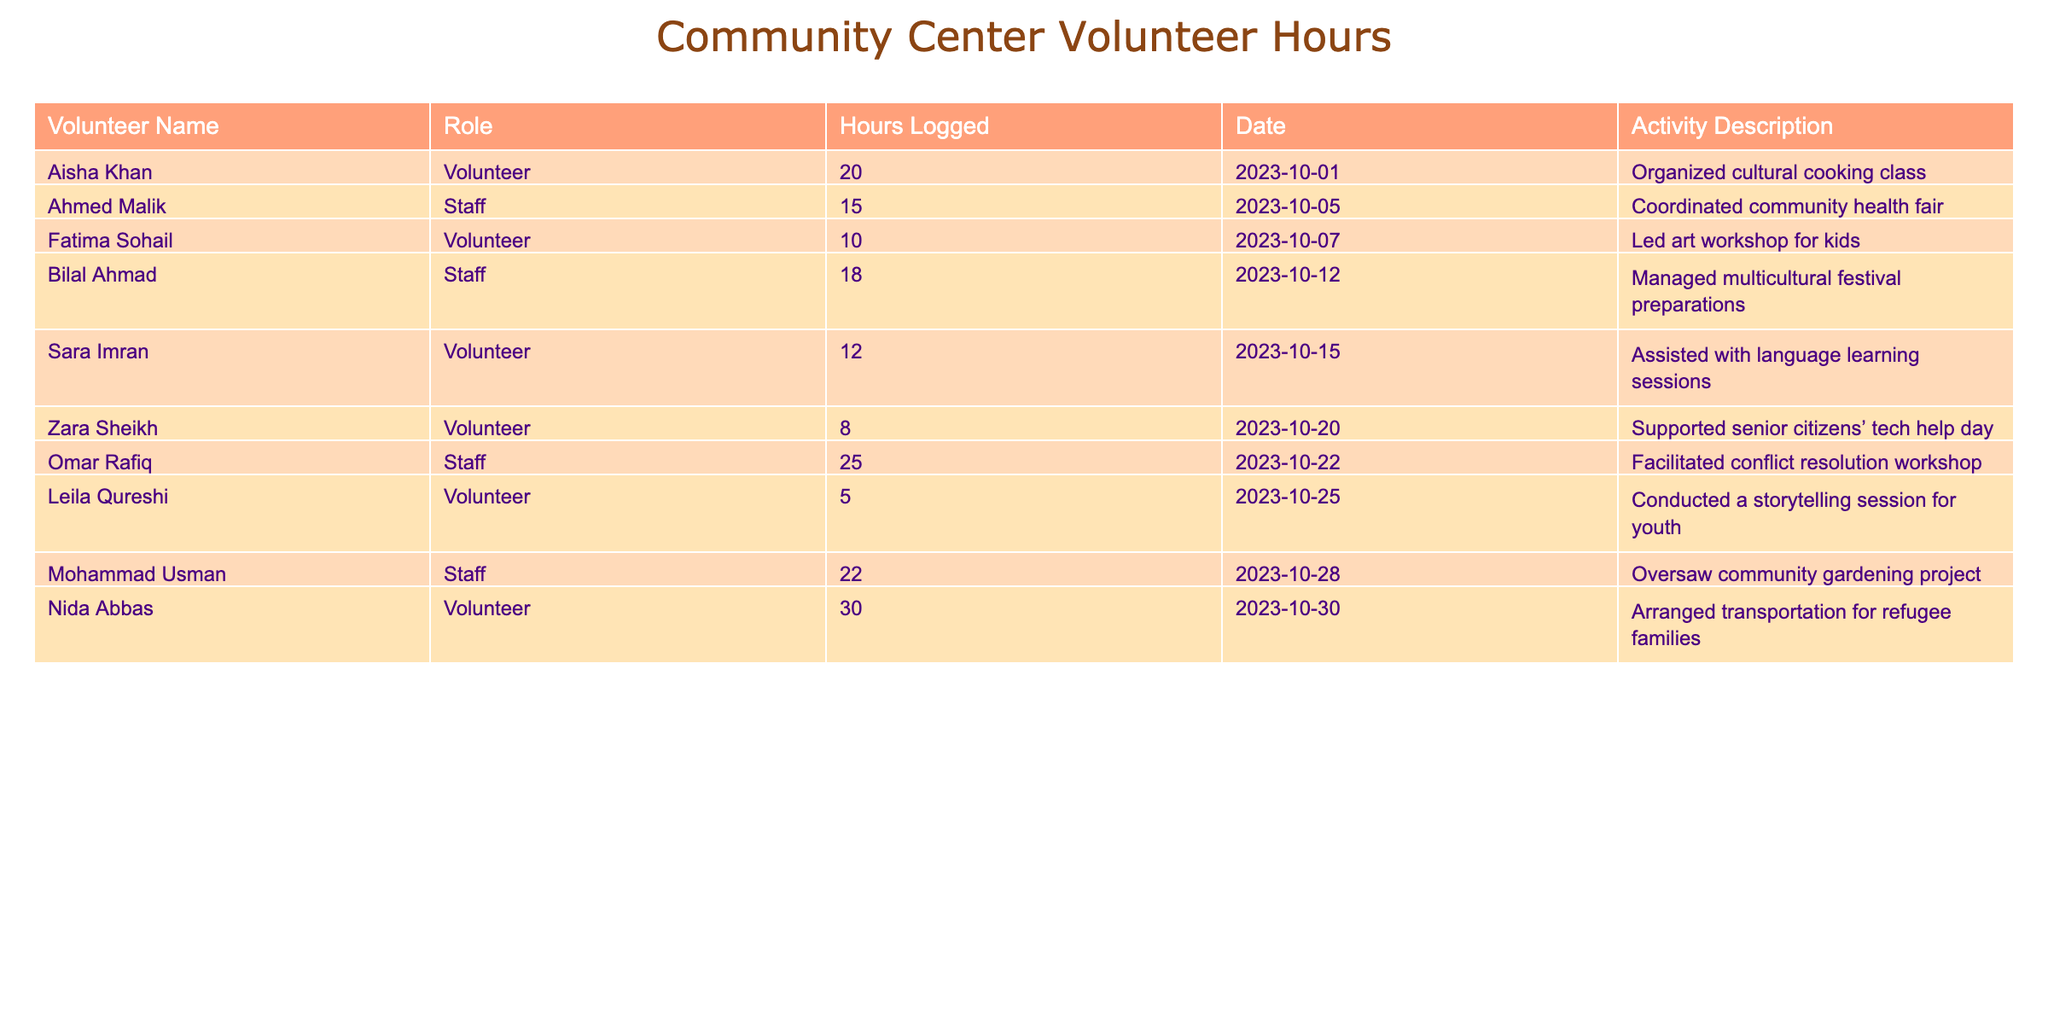What is the total number of volunteer hours logged by all participants? To find the total hours, sum hours for all entries: 20 + 15 + 10 + 18 + 12 + 8 + 25 + 5 + 22 + 30 =  165 hours.
Answer: 165 Who logged the most hours as a volunteer? By inspecting the hours logged by the volunteers, Nida Abbas logged the most with 30 hours, while others logged 20, 10, 12, 8, and 5 hours.
Answer: Nida Abbas How many hours did the staff log in total? The staff hours can be calculated by adding their individual logged hours: 15 + 18 + 25 + 22 = 80 hours.
Answer: 80 Did any volunteers log less than 10 hours? By reviewing the volunteer hours, Leila Qureshi logged 5 hours, which is less than 10.
Answer: Yes What is the average number of hours logged by volunteers? There are 6 volunteers with a total of 20 + 10 + 12 + 8 + 5 + 30 = 85 hours. The average therefore is 85 hours / 6 volunteers = approximately 14.17 hours.
Answer: 14.17 How many volunteers participated in activities involving children? Reviewing the activity descriptions, Fatima Sohail led an art workshop for kids, and Leila Qureshi conducted a storytelling session for youth, making it 2 volunteers.
Answer: 2 What is the difference in hours logged between the volunteer with the most hours and the staff member with the least hours? Nida Abbas logged 30 hours as the highest volunteer, while Ahmed Malik logged 15 hours as the staff member with the least. The difference is 30 - 15 = 15 hours.
Answer: 15 List the activities that received more than 20 logged hours. Activity descriptions can be checked against hours logged: Two activities with over 20 hours: Omar Rafiq (25 hours) and Mohammad Usman (22 hours).
Answer: 2 activities Which activity involved conflict resolution, and who facilitated it? The table indicates that Omar Rafiq facilitated the conflict resolution workshop with 25 hours logged.
Answer: Omar Rafiq facilitated it What percentage of the total hours logged were contributed by volunteers? Volunteers logged 85 hours out of a total of 165 hours. The calculation is (85 / 165) * 100 = 51.52%.
Answer: 51.52% 